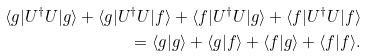<formula> <loc_0><loc_0><loc_500><loc_500>\langle g | U ^ { \dagger } U | g \rangle + \langle g | U ^ { \dagger } U | f \rangle + \langle f | U ^ { \dagger } U | g \rangle + \langle f | U ^ { \dagger } U | f \rangle \\ = \langle g | g \rangle + \langle g | f \rangle + \langle f | g \rangle + \langle f | f \rangle .</formula> 